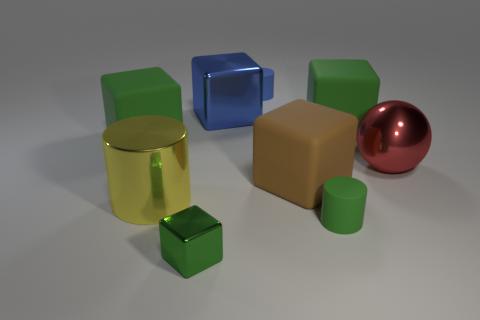There is a green cube that is on the left side of the big brown matte object and behind the tiny metallic thing; how big is it?
Your answer should be compact. Large. There is a big green cube that is on the left side of the green metal cube; what material is it?
Your response must be concise. Rubber. Are there any tiny blue matte things that have the same shape as the tiny shiny thing?
Give a very brief answer. No. How many other red shiny objects are the same shape as the red thing?
Your answer should be compact. 0. Is the size of the green cube to the left of the large metallic cylinder the same as the rubber cylinder in front of the yellow shiny thing?
Keep it short and to the point. No. There is a metallic object behind the matte block on the left side of the tiny shiny thing; what shape is it?
Provide a succinct answer. Cube. Are there the same number of yellow things behind the large red ball and red metallic objects?
Your answer should be compact. No. What material is the block to the left of the metal cube in front of the small matte cylinder that is in front of the big yellow object made of?
Offer a very short reply. Rubber. Are there any red metal spheres of the same size as the brown thing?
Offer a terse response. Yes. There is a large brown matte object; what shape is it?
Ensure brevity in your answer.  Cube. 